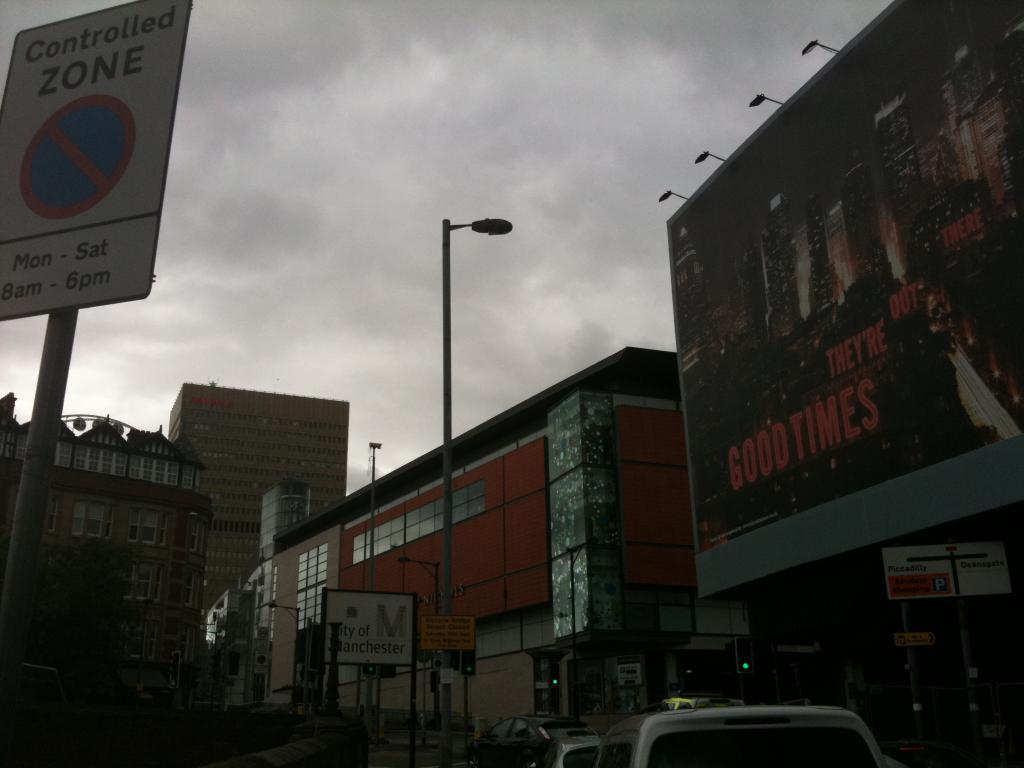Describe this image in one or two sentences. We can see vehicles,boards and lights on poles,hoarding and buildings,above the hoarding we can see lights and we can see sky with clouds. 